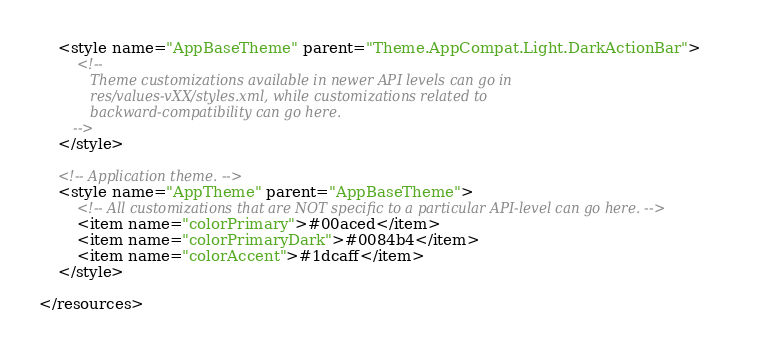Convert code to text. <code><loc_0><loc_0><loc_500><loc_500><_XML_>
    <style name="AppBaseTheme" parent="Theme.AppCompat.Light.DarkActionBar">
        <!--
            Theme customizations available in newer API levels can go in
            res/values-vXX/styles.xml, while customizations related to
            backward-compatibility can go here.
        -->
    </style>

    <!-- Application theme. -->
    <style name="AppTheme" parent="AppBaseTheme">
        <!-- All customizations that are NOT specific to a particular API-level can go here. -->
        <item name="colorPrimary">#00aced</item>
        <item name="colorPrimaryDark">#0084b4</item>
        <item name="colorAccent">#1dcaff</item>
    </style>

</resources>
</code> 